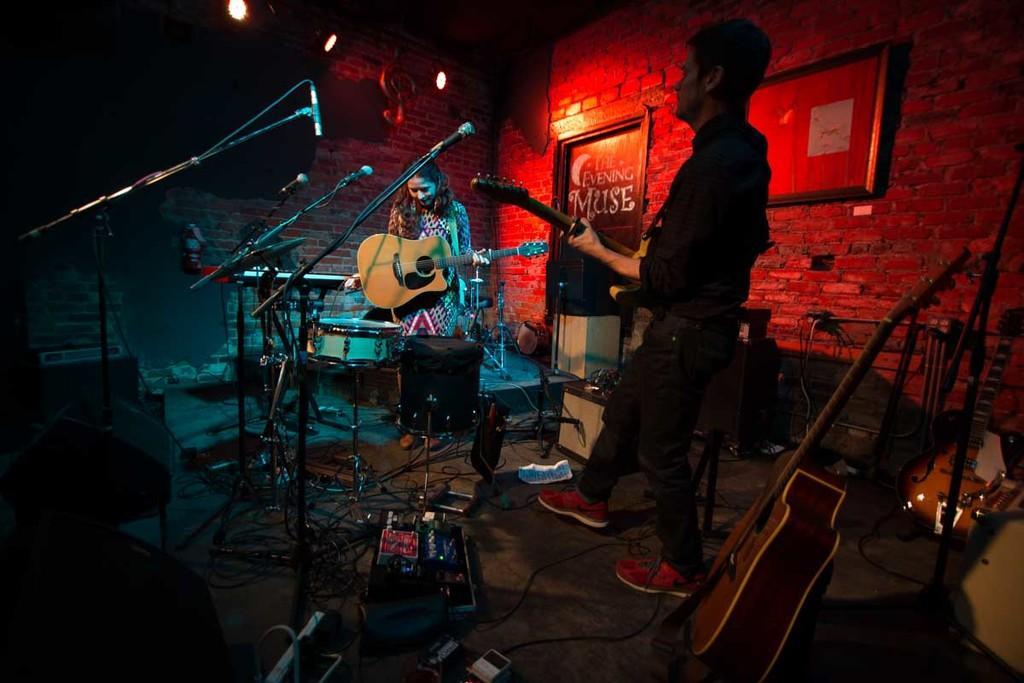Can you describe this image briefly? In this picture we can see a woman and a man playing guitar. These are the mikes. Here we can see musical instruments. On the background there is a wall. These are the lights and there is a door. 